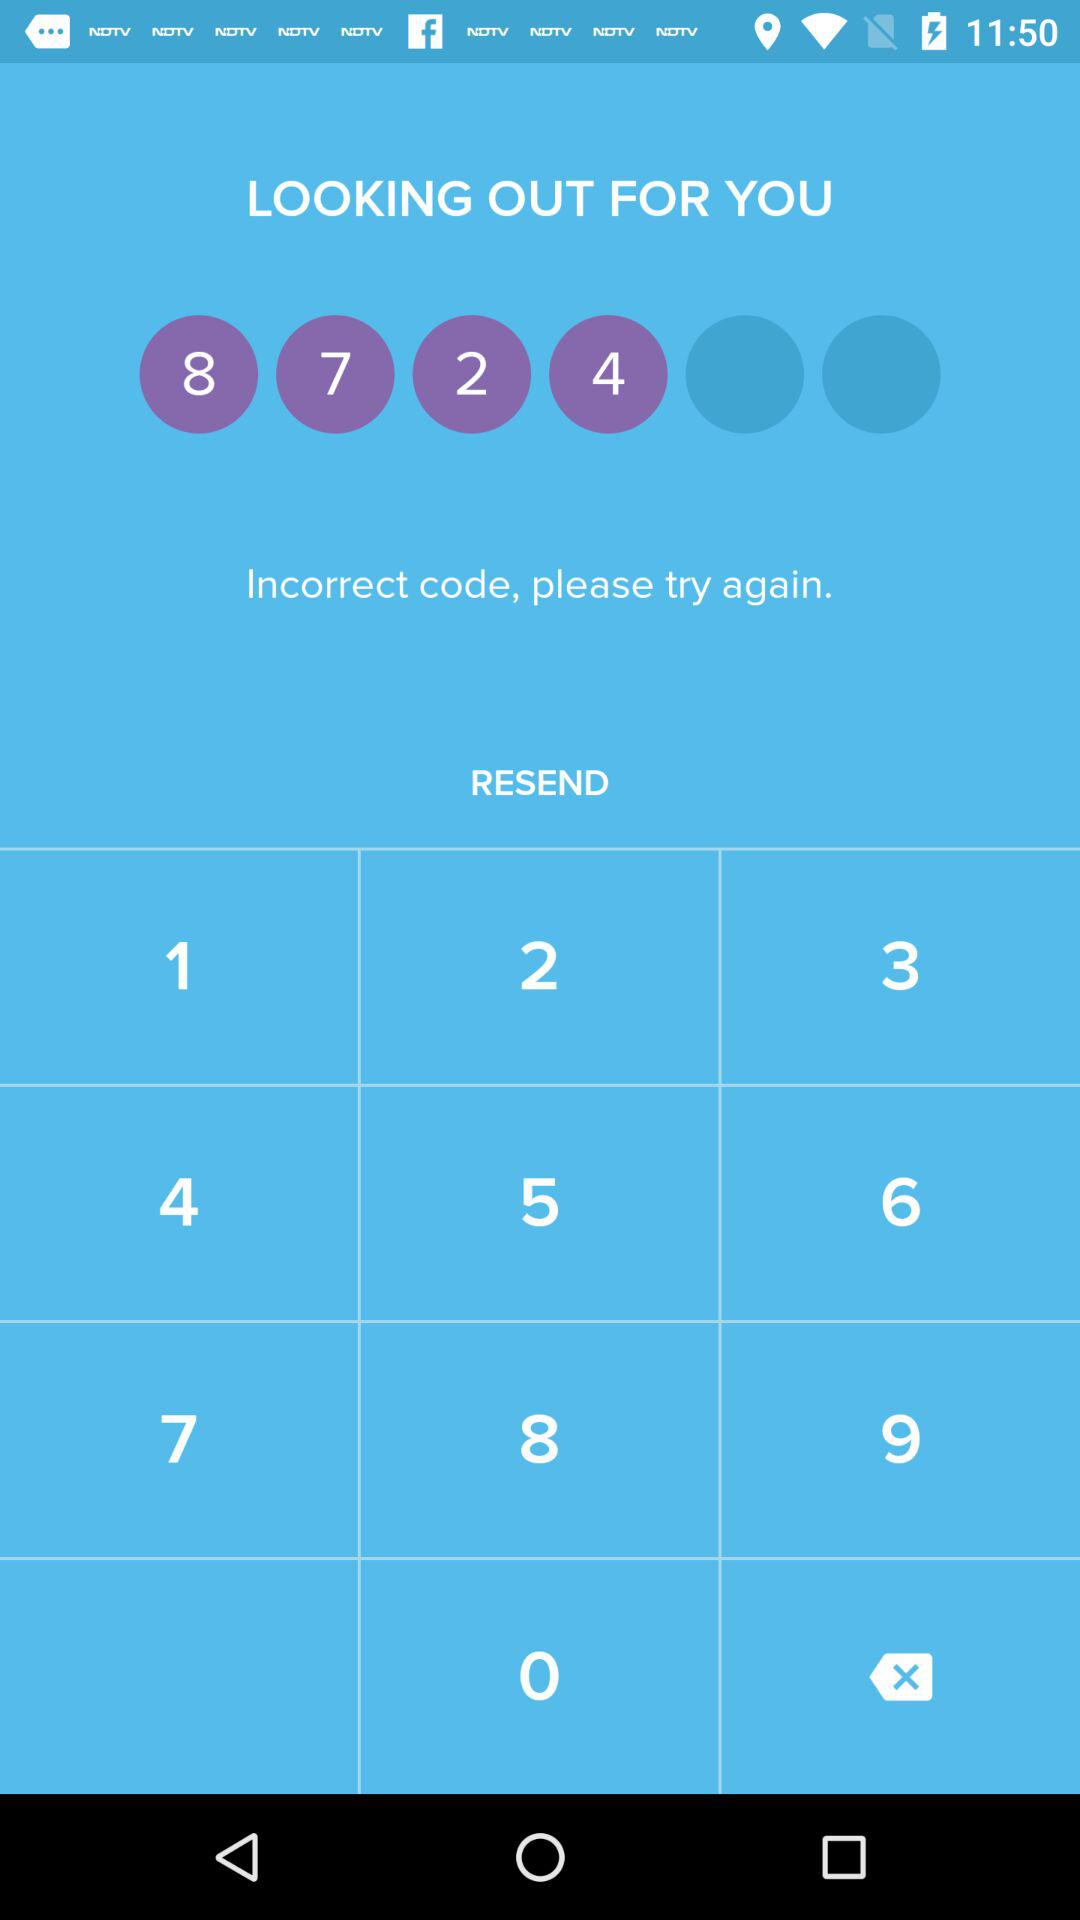What is the incorrect code?
When the provided information is insufficient, respond with <no answer>. <no answer> 